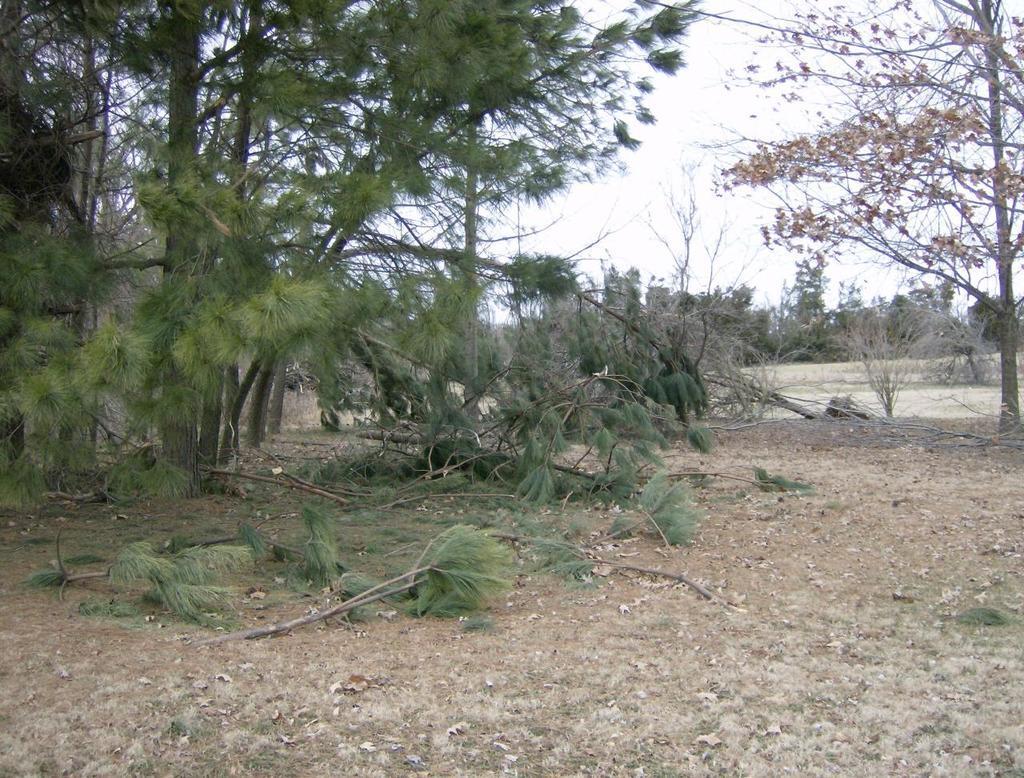How would you summarize this image in a sentence or two? In this picture we can see the sky, trees, dried trees. We can see the dried leaves and branches on the ground. 